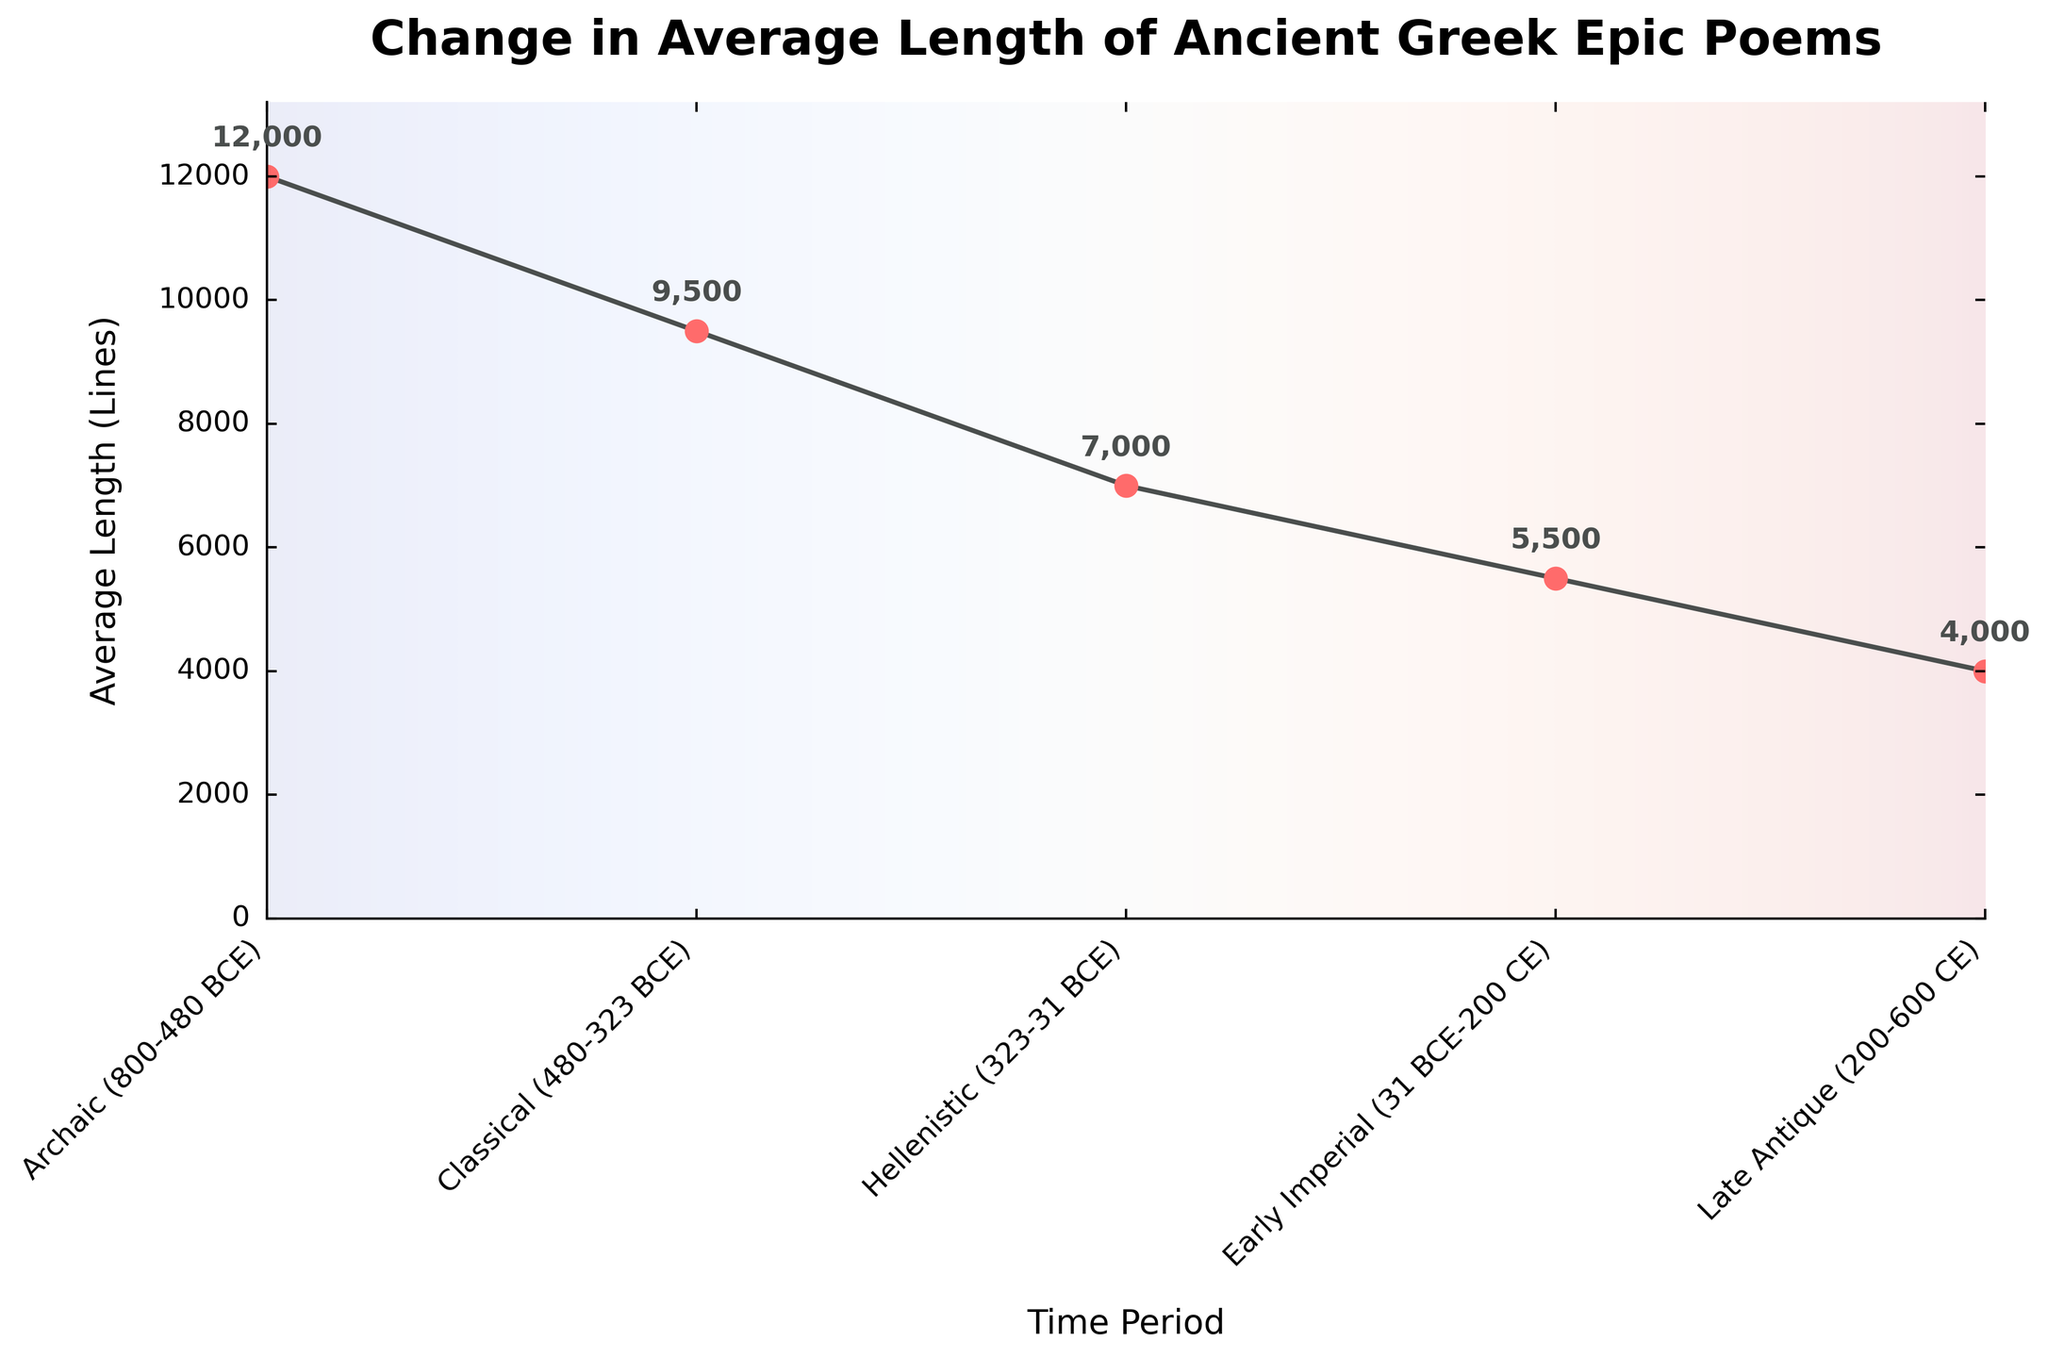What is the trend in the average length of ancient Greek epic poems from the Archaic period to the Late Antique period? The line chart shows a clear downward trend in the average length of epic poems. The length decreases consistently from the Archaic period to the Late Antique period.
Answer: Downward trend How much shorter were the poems on average in the Hellenistic period compared to the Archaic period? Subtract the average length in the Hellenistic period (7000 lines) from the average length in the Archaic period (12000 lines). 12000 - 7000 = 5000.
Answer: 5000 lines During which period did the average length of epic poems decrease the most compared to the previous period? Compare the average length of poems between successive periods and identify the largest decrease. The largest decrease occurred between the Hellenistic (7000 lines) and Early Imperial (5500 lines) periods: 7000 - 5500 = 1500.
Answer: Between Hellenistic and Early Imperial periods What is the percentage decrease in the average length of poems from the Archaic period to the Late Antique period? Use the formula for percentage decrease: ((initial value - final value) / initial value) * 100. So, ((12000 - 4000) / 12000) * 100 = 66.67%.
Answer: 66.67% What is the average length of ancient Greek epic poems across all periods shown in the chart? Sum the average lengths for all periods and divide by the number of periods: (12000 + 9500 + 7000 + 5500 + 4000) / 5 = 7600.
Answer: 7600 lines Which period had the second shortest average length of epic poems? Based on the chart, the second shortest average length of poems is in the Early Imperial period with 5500 lines.
Answer: Early Imperial period How does the average length in the Classical period compare to the average length in the Early Imperial period? The average length of poems in the Classical period is 9500 lines, whereas in the Early Imperial period it is 5500 lines. The Classical period has a 4000 lines longer average length.
Answer: 4000 lines longer What is the visual change in the color gradient from the Archaic period to the Late Antique period on the chart? The color gradient in the background transitions subtly, adding a visual emphasis from the cooler hues to warmer tones as the lengths decrease. This gradient adds a contextual layer indicating change visually.
Answer: Gradient changes from cooler to warmer tones 